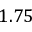<formula> <loc_0><loc_0><loc_500><loc_500>1 . 7 5</formula> 